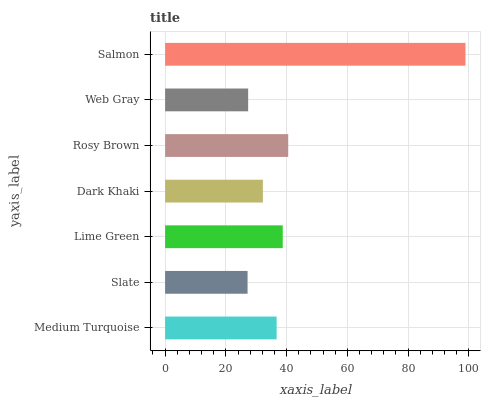Is Slate the minimum?
Answer yes or no. Yes. Is Salmon the maximum?
Answer yes or no. Yes. Is Lime Green the minimum?
Answer yes or no. No. Is Lime Green the maximum?
Answer yes or no. No. Is Lime Green greater than Slate?
Answer yes or no. Yes. Is Slate less than Lime Green?
Answer yes or no. Yes. Is Slate greater than Lime Green?
Answer yes or no. No. Is Lime Green less than Slate?
Answer yes or no. No. Is Medium Turquoise the high median?
Answer yes or no. Yes. Is Medium Turquoise the low median?
Answer yes or no. Yes. Is Rosy Brown the high median?
Answer yes or no. No. Is Rosy Brown the low median?
Answer yes or no. No. 